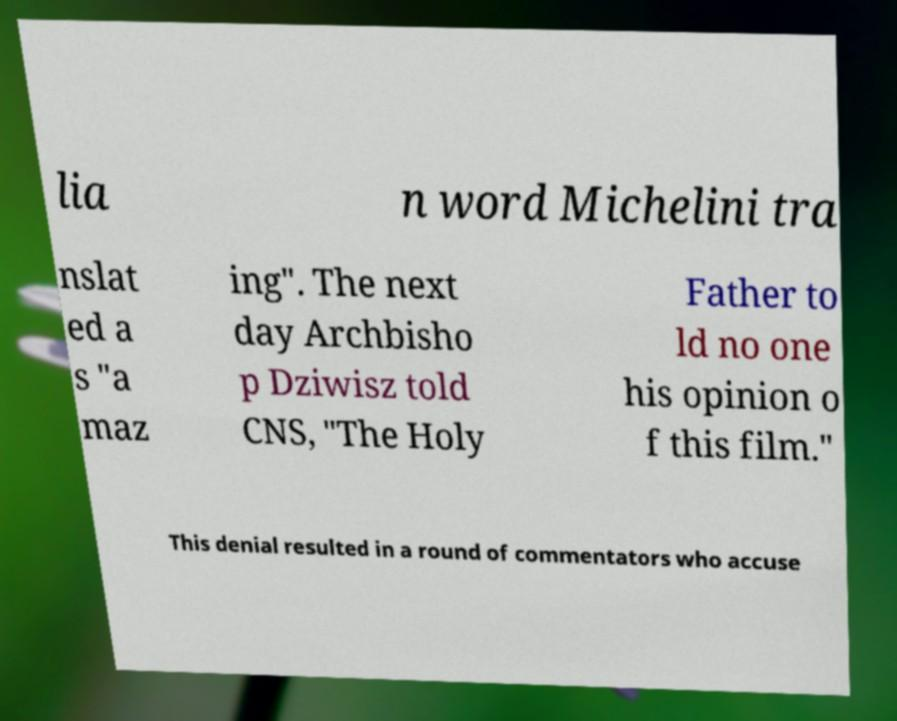I need the written content from this picture converted into text. Can you do that? lia n word Michelini tra nslat ed a s "a maz ing". The next day Archbisho p Dziwisz told CNS, "The Holy Father to ld no one his opinion o f this film." This denial resulted in a round of commentators who accuse 